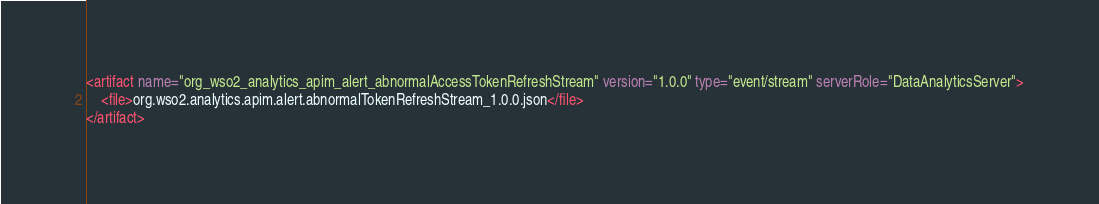<code> <loc_0><loc_0><loc_500><loc_500><_XML_><artifact name="org_wso2_analytics_apim_alert_abnormalAccessTokenRefreshStream" version="1.0.0" type="event/stream" serverRole="DataAnalyticsServer">
    <file>org.wso2.analytics.apim.alert.abnormalTokenRefreshStream_1.0.0.json</file>
</artifact>
</code> 